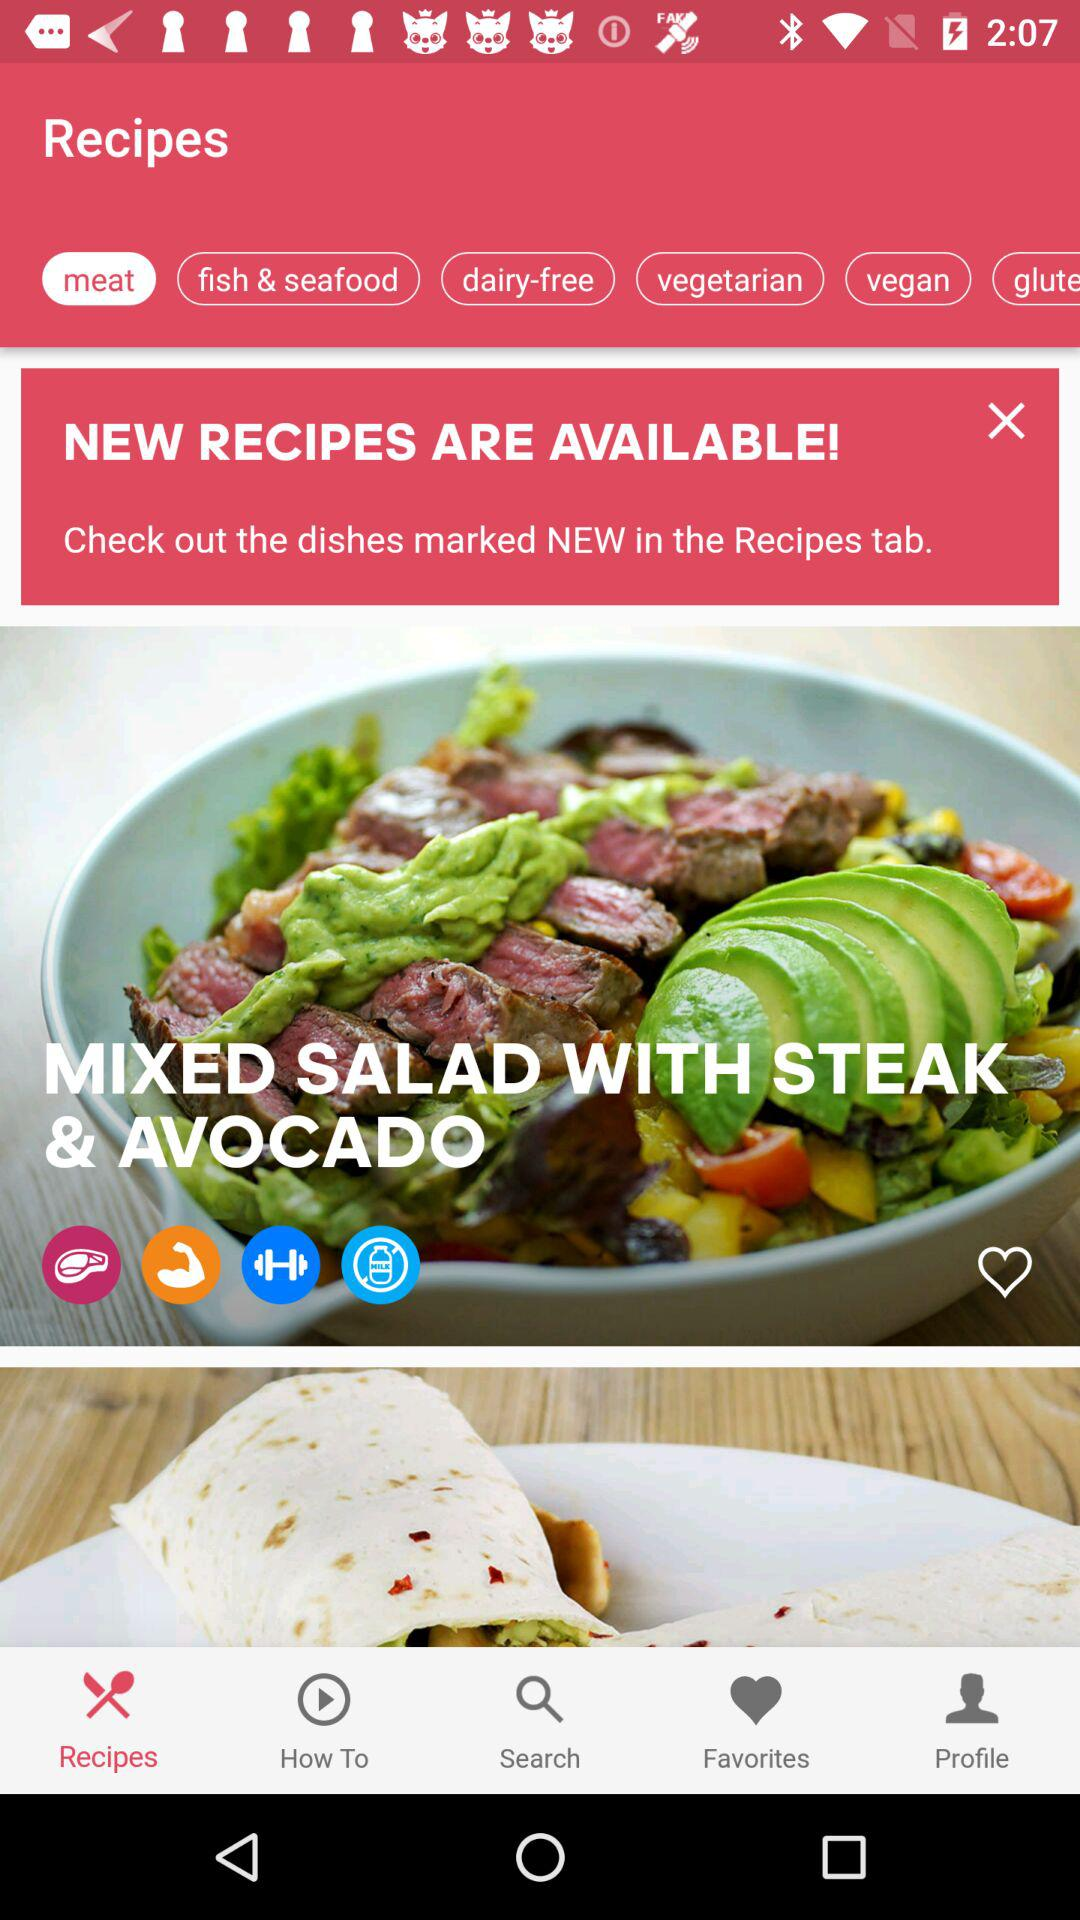What is the recipe shown on the screen? The shown recipe is "Mixed Salad with Steak & Avocado". 